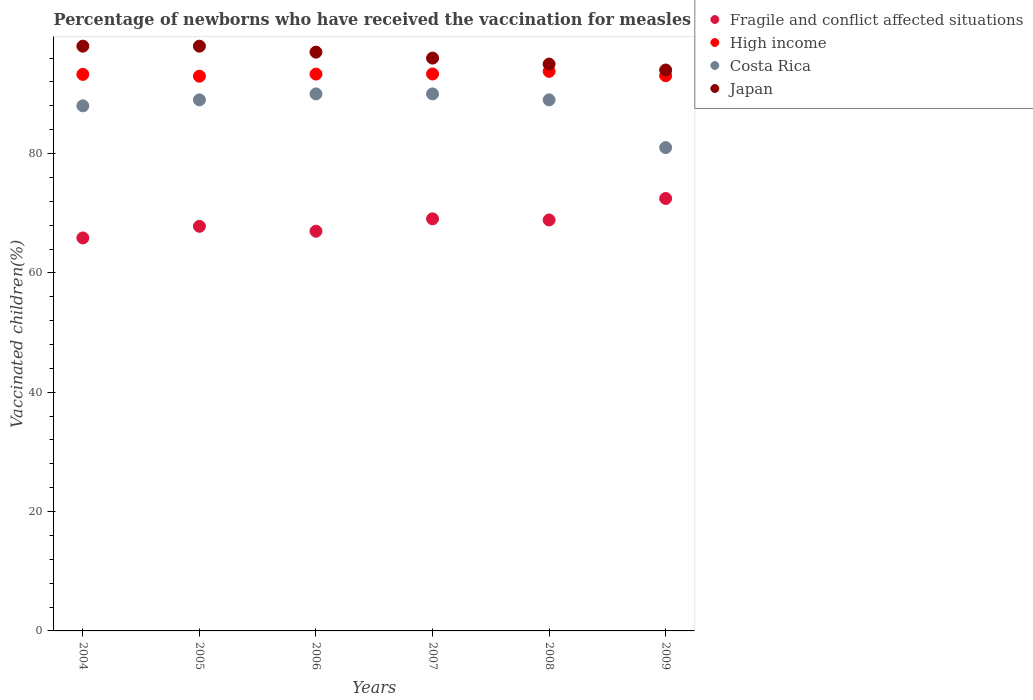How many different coloured dotlines are there?
Give a very brief answer. 4. Is the number of dotlines equal to the number of legend labels?
Your answer should be compact. Yes. What is the percentage of vaccinated children in High income in 2009?
Your answer should be compact. 93.05. Across all years, what is the maximum percentage of vaccinated children in Japan?
Your answer should be compact. 98. Across all years, what is the minimum percentage of vaccinated children in Fragile and conflict affected situations?
Provide a short and direct response. 65.86. What is the total percentage of vaccinated children in Japan in the graph?
Your answer should be compact. 578. What is the difference between the percentage of vaccinated children in Fragile and conflict affected situations in 2004 and that in 2006?
Your answer should be compact. -1.13. What is the difference between the percentage of vaccinated children in High income in 2006 and the percentage of vaccinated children in Japan in 2004?
Give a very brief answer. -4.68. What is the average percentage of vaccinated children in Japan per year?
Your answer should be compact. 96.33. In the year 2009, what is the difference between the percentage of vaccinated children in Fragile and conflict affected situations and percentage of vaccinated children in High income?
Offer a terse response. -20.57. In how many years, is the percentage of vaccinated children in Costa Rica greater than 48 %?
Your answer should be compact. 6. What is the ratio of the percentage of vaccinated children in High income in 2005 to that in 2008?
Your response must be concise. 0.99. What is the difference between the highest and the second highest percentage of vaccinated children in Fragile and conflict affected situations?
Provide a succinct answer. 3.41. What is the difference between the highest and the lowest percentage of vaccinated children in Fragile and conflict affected situations?
Ensure brevity in your answer.  6.61. In how many years, is the percentage of vaccinated children in Japan greater than the average percentage of vaccinated children in Japan taken over all years?
Make the answer very short. 3. Is the sum of the percentage of vaccinated children in Costa Rica in 2008 and 2009 greater than the maximum percentage of vaccinated children in Japan across all years?
Offer a very short reply. Yes. What is the title of the graph?
Offer a terse response. Percentage of newborns who have received the vaccination for measles. What is the label or title of the Y-axis?
Your response must be concise. Vaccinated children(%). What is the Vaccinated children(%) in Fragile and conflict affected situations in 2004?
Provide a succinct answer. 65.86. What is the Vaccinated children(%) of High income in 2004?
Provide a short and direct response. 93.27. What is the Vaccinated children(%) in Costa Rica in 2004?
Your response must be concise. 88. What is the Vaccinated children(%) of Fragile and conflict affected situations in 2005?
Your answer should be very brief. 67.81. What is the Vaccinated children(%) in High income in 2005?
Keep it short and to the point. 92.96. What is the Vaccinated children(%) of Costa Rica in 2005?
Give a very brief answer. 89. What is the Vaccinated children(%) in Japan in 2005?
Make the answer very short. 98. What is the Vaccinated children(%) in Fragile and conflict affected situations in 2006?
Offer a very short reply. 66.99. What is the Vaccinated children(%) in High income in 2006?
Your answer should be very brief. 93.32. What is the Vaccinated children(%) in Japan in 2006?
Give a very brief answer. 97. What is the Vaccinated children(%) in Fragile and conflict affected situations in 2007?
Ensure brevity in your answer.  69.06. What is the Vaccinated children(%) in High income in 2007?
Your answer should be very brief. 93.34. What is the Vaccinated children(%) in Costa Rica in 2007?
Your answer should be compact. 90. What is the Vaccinated children(%) in Japan in 2007?
Offer a terse response. 96. What is the Vaccinated children(%) in Fragile and conflict affected situations in 2008?
Make the answer very short. 68.87. What is the Vaccinated children(%) of High income in 2008?
Make the answer very short. 93.78. What is the Vaccinated children(%) of Costa Rica in 2008?
Provide a short and direct response. 89. What is the Vaccinated children(%) of Fragile and conflict affected situations in 2009?
Your answer should be very brief. 72.47. What is the Vaccinated children(%) in High income in 2009?
Provide a succinct answer. 93.05. What is the Vaccinated children(%) of Japan in 2009?
Offer a terse response. 94. Across all years, what is the maximum Vaccinated children(%) in Fragile and conflict affected situations?
Provide a short and direct response. 72.47. Across all years, what is the maximum Vaccinated children(%) in High income?
Give a very brief answer. 93.78. Across all years, what is the maximum Vaccinated children(%) in Japan?
Your answer should be compact. 98. Across all years, what is the minimum Vaccinated children(%) of Fragile and conflict affected situations?
Make the answer very short. 65.86. Across all years, what is the minimum Vaccinated children(%) in High income?
Your answer should be very brief. 92.96. Across all years, what is the minimum Vaccinated children(%) in Costa Rica?
Provide a succinct answer. 81. Across all years, what is the minimum Vaccinated children(%) of Japan?
Ensure brevity in your answer.  94. What is the total Vaccinated children(%) in Fragile and conflict affected situations in the graph?
Your response must be concise. 411.07. What is the total Vaccinated children(%) in High income in the graph?
Provide a succinct answer. 559.72. What is the total Vaccinated children(%) in Costa Rica in the graph?
Provide a succinct answer. 527. What is the total Vaccinated children(%) of Japan in the graph?
Provide a short and direct response. 578. What is the difference between the Vaccinated children(%) in Fragile and conflict affected situations in 2004 and that in 2005?
Ensure brevity in your answer.  -1.95. What is the difference between the Vaccinated children(%) of High income in 2004 and that in 2005?
Your answer should be compact. 0.31. What is the difference between the Vaccinated children(%) in Costa Rica in 2004 and that in 2005?
Make the answer very short. -1. What is the difference between the Vaccinated children(%) of Japan in 2004 and that in 2005?
Provide a succinct answer. 0. What is the difference between the Vaccinated children(%) of Fragile and conflict affected situations in 2004 and that in 2006?
Your answer should be very brief. -1.13. What is the difference between the Vaccinated children(%) of High income in 2004 and that in 2006?
Ensure brevity in your answer.  -0.05. What is the difference between the Vaccinated children(%) of Japan in 2004 and that in 2006?
Your response must be concise. 1. What is the difference between the Vaccinated children(%) in Fragile and conflict affected situations in 2004 and that in 2007?
Make the answer very short. -3.2. What is the difference between the Vaccinated children(%) in High income in 2004 and that in 2007?
Make the answer very short. -0.07. What is the difference between the Vaccinated children(%) in Costa Rica in 2004 and that in 2007?
Offer a very short reply. -2. What is the difference between the Vaccinated children(%) in Fragile and conflict affected situations in 2004 and that in 2008?
Give a very brief answer. -3.01. What is the difference between the Vaccinated children(%) of High income in 2004 and that in 2008?
Your answer should be very brief. -0.51. What is the difference between the Vaccinated children(%) in Costa Rica in 2004 and that in 2008?
Your answer should be very brief. -1. What is the difference between the Vaccinated children(%) of Fragile and conflict affected situations in 2004 and that in 2009?
Ensure brevity in your answer.  -6.61. What is the difference between the Vaccinated children(%) of High income in 2004 and that in 2009?
Your response must be concise. 0.22. What is the difference between the Vaccinated children(%) of Japan in 2004 and that in 2009?
Your answer should be compact. 4. What is the difference between the Vaccinated children(%) in Fragile and conflict affected situations in 2005 and that in 2006?
Your answer should be compact. 0.82. What is the difference between the Vaccinated children(%) in High income in 2005 and that in 2006?
Your answer should be very brief. -0.36. What is the difference between the Vaccinated children(%) in Costa Rica in 2005 and that in 2006?
Provide a short and direct response. -1. What is the difference between the Vaccinated children(%) in Japan in 2005 and that in 2006?
Your answer should be compact. 1. What is the difference between the Vaccinated children(%) of Fragile and conflict affected situations in 2005 and that in 2007?
Provide a short and direct response. -1.25. What is the difference between the Vaccinated children(%) in High income in 2005 and that in 2007?
Keep it short and to the point. -0.37. What is the difference between the Vaccinated children(%) in Japan in 2005 and that in 2007?
Give a very brief answer. 2. What is the difference between the Vaccinated children(%) in Fragile and conflict affected situations in 2005 and that in 2008?
Provide a short and direct response. -1.06. What is the difference between the Vaccinated children(%) in High income in 2005 and that in 2008?
Make the answer very short. -0.81. What is the difference between the Vaccinated children(%) of Costa Rica in 2005 and that in 2008?
Your answer should be very brief. 0. What is the difference between the Vaccinated children(%) of Japan in 2005 and that in 2008?
Your answer should be very brief. 3. What is the difference between the Vaccinated children(%) of Fragile and conflict affected situations in 2005 and that in 2009?
Ensure brevity in your answer.  -4.67. What is the difference between the Vaccinated children(%) of High income in 2005 and that in 2009?
Offer a terse response. -0.08. What is the difference between the Vaccinated children(%) of Fragile and conflict affected situations in 2006 and that in 2007?
Offer a very short reply. -2.07. What is the difference between the Vaccinated children(%) in High income in 2006 and that in 2007?
Offer a very short reply. -0.02. What is the difference between the Vaccinated children(%) in Japan in 2006 and that in 2007?
Provide a short and direct response. 1. What is the difference between the Vaccinated children(%) in Fragile and conflict affected situations in 2006 and that in 2008?
Your answer should be very brief. -1.88. What is the difference between the Vaccinated children(%) of High income in 2006 and that in 2008?
Your answer should be very brief. -0.46. What is the difference between the Vaccinated children(%) in Japan in 2006 and that in 2008?
Provide a succinct answer. 2. What is the difference between the Vaccinated children(%) of Fragile and conflict affected situations in 2006 and that in 2009?
Ensure brevity in your answer.  -5.49. What is the difference between the Vaccinated children(%) in High income in 2006 and that in 2009?
Keep it short and to the point. 0.27. What is the difference between the Vaccinated children(%) in Costa Rica in 2006 and that in 2009?
Your answer should be compact. 9. What is the difference between the Vaccinated children(%) of Fragile and conflict affected situations in 2007 and that in 2008?
Make the answer very short. 0.19. What is the difference between the Vaccinated children(%) in High income in 2007 and that in 2008?
Keep it short and to the point. -0.44. What is the difference between the Vaccinated children(%) in Costa Rica in 2007 and that in 2008?
Give a very brief answer. 1. What is the difference between the Vaccinated children(%) in Japan in 2007 and that in 2008?
Keep it short and to the point. 1. What is the difference between the Vaccinated children(%) in Fragile and conflict affected situations in 2007 and that in 2009?
Offer a very short reply. -3.41. What is the difference between the Vaccinated children(%) of High income in 2007 and that in 2009?
Keep it short and to the point. 0.29. What is the difference between the Vaccinated children(%) of Costa Rica in 2007 and that in 2009?
Your response must be concise. 9. What is the difference between the Vaccinated children(%) in Fragile and conflict affected situations in 2008 and that in 2009?
Keep it short and to the point. -3.6. What is the difference between the Vaccinated children(%) of High income in 2008 and that in 2009?
Offer a very short reply. 0.73. What is the difference between the Vaccinated children(%) in Fragile and conflict affected situations in 2004 and the Vaccinated children(%) in High income in 2005?
Give a very brief answer. -27.1. What is the difference between the Vaccinated children(%) in Fragile and conflict affected situations in 2004 and the Vaccinated children(%) in Costa Rica in 2005?
Your answer should be compact. -23.14. What is the difference between the Vaccinated children(%) in Fragile and conflict affected situations in 2004 and the Vaccinated children(%) in Japan in 2005?
Your answer should be compact. -32.14. What is the difference between the Vaccinated children(%) in High income in 2004 and the Vaccinated children(%) in Costa Rica in 2005?
Provide a short and direct response. 4.27. What is the difference between the Vaccinated children(%) of High income in 2004 and the Vaccinated children(%) of Japan in 2005?
Provide a short and direct response. -4.73. What is the difference between the Vaccinated children(%) of Costa Rica in 2004 and the Vaccinated children(%) of Japan in 2005?
Provide a short and direct response. -10. What is the difference between the Vaccinated children(%) in Fragile and conflict affected situations in 2004 and the Vaccinated children(%) in High income in 2006?
Give a very brief answer. -27.46. What is the difference between the Vaccinated children(%) in Fragile and conflict affected situations in 2004 and the Vaccinated children(%) in Costa Rica in 2006?
Offer a very short reply. -24.14. What is the difference between the Vaccinated children(%) of Fragile and conflict affected situations in 2004 and the Vaccinated children(%) of Japan in 2006?
Make the answer very short. -31.14. What is the difference between the Vaccinated children(%) in High income in 2004 and the Vaccinated children(%) in Costa Rica in 2006?
Offer a terse response. 3.27. What is the difference between the Vaccinated children(%) of High income in 2004 and the Vaccinated children(%) of Japan in 2006?
Your answer should be compact. -3.73. What is the difference between the Vaccinated children(%) in Fragile and conflict affected situations in 2004 and the Vaccinated children(%) in High income in 2007?
Ensure brevity in your answer.  -27.48. What is the difference between the Vaccinated children(%) in Fragile and conflict affected situations in 2004 and the Vaccinated children(%) in Costa Rica in 2007?
Give a very brief answer. -24.14. What is the difference between the Vaccinated children(%) in Fragile and conflict affected situations in 2004 and the Vaccinated children(%) in Japan in 2007?
Your response must be concise. -30.14. What is the difference between the Vaccinated children(%) in High income in 2004 and the Vaccinated children(%) in Costa Rica in 2007?
Make the answer very short. 3.27. What is the difference between the Vaccinated children(%) in High income in 2004 and the Vaccinated children(%) in Japan in 2007?
Your answer should be compact. -2.73. What is the difference between the Vaccinated children(%) in Fragile and conflict affected situations in 2004 and the Vaccinated children(%) in High income in 2008?
Your answer should be very brief. -27.92. What is the difference between the Vaccinated children(%) in Fragile and conflict affected situations in 2004 and the Vaccinated children(%) in Costa Rica in 2008?
Your answer should be very brief. -23.14. What is the difference between the Vaccinated children(%) in Fragile and conflict affected situations in 2004 and the Vaccinated children(%) in Japan in 2008?
Provide a short and direct response. -29.14. What is the difference between the Vaccinated children(%) in High income in 2004 and the Vaccinated children(%) in Costa Rica in 2008?
Ensure brevity in your answer.  4.27. What is the difference between the Vaccinated children(%) of High income in 2004 and the Vaccinated children(%) of Japan in 2008?
Offer a terse response. -1.73. What is the difference between the Vaccinated children(%) of Fragile and conflict affected situations in 2004 and the Vaccinated children(%) of High income in 2009?
Provide a succinct answer. -27.19. What is the difference between the Vaccinated children(%) in Fragile and conflict affected situations in 2004 and the Vaccinated children(%) in Costa Rica in 2009?
Offer a very short reply. -15.14. What is the difference between the Vaccinated children(%) in Fragile and conflict affected situations in 2004 and the Vaccinated children(%) in Japan in 2009?
Make the answer very short. -28.14. What is the difference between the Vaccinated children(%) in High income in 2004 and the Vaccinated children(%) in Costa Rica in 2009?
Make the answer very short. 12.27. What is the difference between the Vaccinated children(%) in High income in 2004 and the Vaccinated children(%) in Japan in 2009?
Give a very brief answer. -0.73. What is the difference between the Vaccinated children(%) in Fragile and conflict affected situations in 2005 and the Vaccinated children(%) in High income in 2006?
Offer a terse response. -25.51. What is the difference between the Vaccinated children(%) of Fragile and conflict affected situations in 2005 and the Vaccinated children(%) of Costa Rica in 2006?
Make the answer very short. -22.19. What is the difference between the Vaccinated children(%) of Fragile and conflict affected situations in 2005 and the Vaccinated children(%) of Japan in 2006?
Offer a very short reply. -29.19. What is the difference between the Vaccinated children(%) of High income in 2005 and the Vaccinated children(%) of Costa Rica in 2006?
Give a very brief answer. 2.96. What is the difference between the Vaccinated children(%) in High income in 2005 and the Vaccinated children(%) in Japan in 2006?
Offer a very short reply. -4.04. What is the difference between the Vaccinated children(%) in Costa Rica in 2005 and the Vaccinated children(%) in Japan in 2006?
Provide a short and direct response. -8. What is the difference between the Vaccinated children(%) of Fragile and conflict affected situations in 2005 and the Vaccinated children(%) of High income in 2007?
Provide a short and direct response. -25.53. What is the difference between the Vaccinated children(%) of Fragile and conflict affected situations in 2005 and the Vaccinated children(%) of Costa Rica in 2007?
Your answer should be compact. -22.19. What is the difference between the Vaccinated children(%) in Fragile and conflict affected situations in 2005 and the Vaccinated children(%) in Japan in 2007?
Your response must be concise. -28.19. What is the difference between the Vaccinated children(%) of High income in 2005 and the Vaccinated children(%) of Costa Rica in 2007?
Offer a terse response. 2.96. What is the difference between the Vaccinated children(%) in High income in 2005 and the Vaccinated children(%) in Japan in 2007?
Your answer should be very brief. -3.04. What is the difference between the Vaccinated children(%) in Fragile and conflict affected situations in 2005 and the Vaccinated children(%) in High income in 2008?
Provide a succinct answer. -25.97. What is the difference between the Vaccinated children(%) of Fragile and conflict affected situations in 2005 and the Vaccinated children(%) of Costa Rica in 2008?
Offer a terse response. -21.19. What is the difference between the Vaccinated children(%) in Fragile and conflict affected situations in 2005 and the Vaccinated children(%) in Japan in 2008?
Provide a short and direct response. -27.19. What is the difference between the Vaccinated children(%) of High income in 2005 and the Vaccinated children(%) of Costa Rica in 2008?
Your response must be concise. 3.96. What is the difference between the Vaccinated children(%) of High income in 2005 and the Vaccinated children(%) of Japan in 2008?
Make the answer very short. -2.04. What is the difference between the Vaccinated children(%) in Costa Rica in 2005 and the Vaccinated children(%) in Japan in 2008?
Your response must be concise. -6. What is the difference between the Vaccinated children(%) of Fragile and conflict affected situations in 2005 and the Vaccinated children(%) of High income in 2009?
Provide a short and direct response. -25.24. What is the difference between the Vaccinated children(%) in Fragile and conflict affected situations in 2005 and the Vaccinated children(%) in Costa Rica in 2009?
Your response must be concise. -13.19. What is the difference between the Vaccinated children(%) of Fragile and conflict affected situations in 2005 and the Vaccinated children(%) of Japan in 2009?
Give a very brief answer. -26.19. What is the difference between the Vaccinated children(%) in High income in 2005 and the Vaccinated children(%) in Costa Rica in 2009?
Keep it short and to the point. 11.96. What is the difference between the Vaccinated children(%) of High income in 2005 and the Vaccinated children(%) of Japan in 2009?
Offer a terse response. -1.04. What is the difference between the Vaccinated children(%) of Costa Rica in 2005 and the Vaccinated children(%) of Japan in 2009?
Offer a very short reply. -5. What is the difference between the Vaccinated children(%) in Fragile and conflict affected situations in 2006 and the Vaccinated children(%) in High income in 2007?
Keep it short and to the point. -26.35. What is the difference between the Vaccinated children(%) of Fragile and conflict affected situations in 2006 and the Vaccinated children(%) of Costa Rica in 2007?
Offer a terse response. -23.01. What is the difference between the Vaccinated children(%) of Fragile and conflict affected situations in 2006 and the Vaccinated children(%) of Japan in 2007?
Your answer should be compact. -29.01. What is the difference between the Vaccinated children(%) in High income in 2006 and the Vaccinated children(%) in Costa Rica in 2007?
Your answer should be compact. 3.32. What is the difference between the Vaccinated children(%) in High income in 2006 and the Vaccinated children(%) in Japan in 2007?
Give a very brief answer. -2.68. What is the difference between the Vaccinated children(%) in Costa Rica in 2006 and the Vaccinated children(%) in Japan in 2007?
Your response must be concise. -6. What is the difference between the Vaccinated children(%) in Fragile and conflict affected situations in 2006 and the Vaccinated children(%) in High income in 2008?
Your answer should be compact. -26.79. What is the difference between the Vaccinated children(%) of Fragile and conflict affected situations in 2006 and the Vaccinated children(%) of Costa Rica in 2008?
Offer a terse response. -22.01. What is the difference between the Vaccinated children(%) of Fragile and conflict affected situations in 2006 and the Vaccinated children(%) of Japan in 2008?
Make the answer very short. -28.01. What is the difference between the Vaccinated children(%) in High income in 2006 and the Vaccinated children(%) in Costa Rica in 2008?
Offer a terse response. 4.32. What is the difference between the Vaccinated children(%) of High income in 2006 and the Vaccinated children(%) of Japan in 2008?
Offer a very short reply. -1.68. What is the difference between the Vaccinated children(%) in Costa Rica in 2006 and the Vaccinated children(%) in Japan in 2008?
Offer a very short reply. -5. What is the difference between the Vaccinated children(%) in Fragile and conflict affected situations in 2006 and the Vaccinated children(%) in High income in 2009?
Offer a terse response. -26.06. What is the difference between the Vaccinated children(%) of Fragile and conflict affected situations in 2006 and the Vaccinated children(%) of Costa Rica in 2009?
Your response must be concise. -14.01. What is the difference between the Vaccinated children(%) of Fragile and conflict affected situations in 2006 and the Vaccinated children(%) of Japan in 2009?
Ensure brevity in your answer.  -27.01. What is the difference between the Vaccinated children(%) in High income in 2006 and the Vaccinated children(%) in Costa Rica in 2009?
Provide a succinct answer. 12.32. What is the difference between the Vaccinated children(%) in High income in 2006 and the Vaccinated children(%) in Japan in 2009?
Ensure brevity in your answer.  -0.68. What is the difference between the Vaccinated children(%) of Costa Rica in 2006 and the Vaccinated children(%) of Japan in 2009?
Make the answer very short. -4. What is the difference between the Vaccinated children(%) of Fragile and conflict affected situations in 2007 and the Vaccinated children(%) of High income in 2008?
Offer a very short reply. -24.72. What is the difference between the Vaccinated children(%) of Fragile and conflict affected situations in 2007 and the Vaccinated children(%) of Costa Rica in 2008?
Offer a very short reply. -19.94. What is the difference between the Vaccinated children(%) in Fragile and conflict affected situations in 2007 and the Vaccinated children(%) in Japan in 2008?
Your answer should be very brief. -25.94. What is the difference between the Vaccinated children(%) in High income in 2007 and the Vaccinated children(%) in Costa Rica in 2008?
Provide a succinct answer. 4.34. What is the difference between the Vaccinated children(%) of High income in 2007 and the Vaccinated children(%) of Japan in 2008?
Provide a short and direct response. -1.66. What is the difference between the Vaccinated children(%) of Costa Rica in 2007 and the Vaccinated children(%) of Japan in 2008?
Provide a short and direct response. -5. What is the difference between the Vaccinated children(%) of Fragile and conflict affected situations in 2007 and the Vaccinated children(%) of High income in 2009?
Ensure brevity in your answer.  -23.99. What is the difference between the Vaccinated children(%) of Fragile and conflict affected situations in 2007 and the Vaccinated children(%) of Costa Rica in 2009?
Offer a terse response. -11.94. What is the difference between the Vaccinated children(%) in Fragile and conflict affected situations in 2007 and the Vaccinated children(%) in Japan in 2009?
Provide a succinct answer. -24.94. What is the difference between the Vaccinated children(%) of High income in 2007 and the Vaccinated children(%) of Costa Rica in 2009?
Ensure brevity in your answer.  12.34. What is the difference between the Vaccinated children(%) of High income in 2007 and the Vaccinated children(%) of Japan in 2009?
Ensure brevity in your answer.  -0.66. What is the difference between the Vaccinated children(%) of Fragile and conflict affected situations in 2008 and the Vaccinated children(%) of High income in 2009?
Make the answer very short. -24.18. What is the difference between the Vaccinated children(%) of Fragile and conflict affected situations in 2008 and the Vaccinated children(%) of Costa Rica in 2009?
Your response must be concise. -12.13. What is the difference between the Vaccinated children(%) of Fragile and conflict affected situations in 2008 and the Vaccinated children(%) of Japan in 2009?
Offer a terse response. -25.13. What is the difference between the Vaccinated children(%) in High income in 2008 and the Vaccinated children(%) in Costa Rica in 2009?
Make the answer very short. 12.78. What is the difference between the Vaccinated children(%) in High income in 2008 and the Vaccinated children(%) in Japan in 2009?
Provide a short and direct response. -0.22. What is the average Vaccinated children(%) in Fragile and conflict affected situations per year?
Provide a succinct answer. 68.51. What is the average Vaccinated children(%) in High income per year?
Ensure brevity in your answer.  93.29. What is the average Vaccinated children(%) in Costa Rica per year?
Your response must be concise. 87.83. What is the average Vaccinated children(%) of Japan per year?
Keep it short and to the point. 96.33. In the year 2004, what is the difference between the Vaccinated children(%) in Fragile and conflict affected situations and Vaccinated children(%) in High income?
Offer a terse response. -27.41. In the year 2004, what is the difference between the Vaccinated children(%) of Fragile and conflict affected situations and Vaccinated children(%) of Costa Rica?
Give a very brief answer. -22.14. In the year 2004, what is the difference between the Vaccinated children(%) of Fragile and conflict affected situations and Vaccinated children(%) of Japan?
Provide a short and direct response. -32.14. In the year 2004, what is the difference between the Vaccinated children(%) of High income and Vaccinated children(%) of Costa Rica?
Provide a succinct answer. 5.27. In the year 2004, what is the difference between the Vaccinated children(%) in High income and Vaccinated children(%) in Japan?
Make the answer very short. -4.73. In the year 2004, what is the difference between the Vaccinated children(%) of Costa Rica and Vaccinated children(%) of Japan?
Ensure brevity in your answer.  -10. In the year 2005, what is the difference between the Vaccinated children(%) in Fragile and conflict affected situations and Vaccinated children(%) in High income?
Ensure brevity in your answer.  -25.16. In the year 2005, what is the difference between the Vaccinated children(%) of Fragile and conflict affected situations and Vaccinated children(%) of Costa Rica?
Ensure brevity in your answer.  -21.19. In the year 2005, what is the difference between the Vaccinated children(%) in Fragile and conflict affected situations and Vaccinated children(%) in Japan?
Make the answer very short. -30.19. In the year 2005, what is the difference between the Vaccinated children(%) in High income and Vaccinated children(%) in Costa Rica?
Offer a terse response. 3.96. In the year 2005, what is the difference between the Vaccinated children(%) in High income and Vaccinated children(%) in Japan?
Your response must be concise. -5.04. In the year 2005, what is the difference between the Vaccinated children(%) of Costa Rica and Vaccinated children(%) of Japan?
Provide a succinct answer. -9. In the year 2006, what is the difference between the Vaccinated children(%) in Fragile and conflict affected situations and Vaccinated children(%) in High income?
Your answer should be very brief. -26.33. In the year 2006, what is the difference between the Vaccinated children(%) of Fragile and conflict affected situations and Vaccinated children(%) of Costa Rica?
Offer a very short reply. -23.01. In the year 2006, what is the difference between the Vaccinated children(%) in Fragile and conflict affected situations and Vaccinated children(%) in Japan?
Provide a succinct answer. -30.01. In the year 2006, what is the difference between the Vaccinated children(%) in High income and Vaccinated children(%) in Costa Rica?
Make the answer very short. 3.32. In the year 2006, what is the difference between the Vaccinated children(%) in High income and Vaccinated children(%) in Japan?
Provide a short and direct response. -3.68. In the year 2006, what is the difference between the Vaccinated children(%) in Costa Rica and Vaccinated children(%) in Japan?
Provide a short and direct response. -7. In the year 2007, what is the difference between the Vaccinated children(%) of Fragile and conflict affected situations and Vaccinated children(%) of High income?
Give a very brief answer. -24.28. In the year 2007, what is the difference between the Vaccinated children(%) in Fragile and conflict affected situations and Vaccinated children(%) in Costa Rica?
Keep it short and to the point. -20.94. In the year 2007, what is the difference between the Vaccinated children(%) in Fragile and conflict affected situations and Vaccinated children(%) in Japan?
Ensure brevity in your answer.  -26.94. In the year 2007, what is the difference between the Vaccinated children(%) in High income and Vaccinated children(%) in Costa Rica?
Offer a terse response. 3.34. In the year 2007, what is the difference between the Vaccinated children(%) of High income and Vaccinated children(%) of Japan?
Provide a succinct answer. -2.66. In the year 2008, what is the difference between the Vaccinated children(%) in Fragile and conflict affected situations and Vaccinated children(%) in High income?
Your answer should be compact. -24.91. In the year 2008, what is the difference between the Vaccinated children(%) of Fragile and conflict affected situations and Vaccinated children(%) of Costa Rica?
Give a very brief answer. -20.13. In the year 2008, what is the difference between the Vaccinated children(%) of Fragile and conflict affected situations and Vaccinated children(%) of Japan?
Ensure brevity in your answer.  -26.13. In the year 2008, what is the difference between the Vaccinated children(%) in High income and Vaccinated children(%) in Costa Rica?
Your response must be concise. 4.78. In the year 2008, what is the difference between the Vaccinated children(%) of High income and Vaccinated children(%) of Japan?
Offer a terse response. -1.22. In the year 2008, what is the difference between the Vaccinated children(%) of Costa Rica and Vaccinated children(%) of Japan?
Offer a very short reply. -6. In the year 2009, what is the difference between the Vaccinated children(%) in Fragile and conflict affected situations and Vaccinated children(%) in High income?
Keep it short and to the point. -20.57. In the year 2009, what is the difference between the Vaccinated children(%) in Fragile and conflict affected situations and Vaccinated children(%) in Costa Rica?
Your response must be concise. -8.53. In the year 2009, what is the difference between the Vaccinated children(%) of Fragile and conflict affected situations and Vaccinated children(%) of Japan?
Ensure brevity in your answer.  -21.53. In the year 2009, what is the difference between the Vaccinated children(%) of High income and Vaccinated children(%) of Costa Rica?
Make the answer very short. 12.05. In the year 2009, what is the difference between the Vaccinated children(%) of High income and Vaccinated children(%) of Japan?
Provide a succinct answer. -0.95. In the year 2009, what is the difference between the Vaccinated children(%) in Costa Rica and Vaccinated children(%) in Japan?
Provide a short and direct response. -13. What is the ratio of the Vaccinated children(%) in Fragile and conflict affected situations in 2004 to that in 2005?
Your response must be concise. 0.97. What is the ratio of the Vaccinated children(%) in Costa Rica in 2004 to that in 2005?
Keep it short and to the point. 0.99. What is the ratio of the Vaccinated children(%) in Japan in 2004 to that in 2005?
Your answer should be compact. 1. What is the ratio of the Vaccinated children(%) in Fragile and conflict affected situations in 2004 to that in 2006?
Provide a short and direct response. 0.98. What is the ratio of the Vaccinated children(%) in High income in 2004 to that in 2006?
Offer a terse response. 1. What is the ratio of the Vaccinated children(%) in Costa Rica in 2004 to that in 2006?
Provide a short and direct response. 0.98. What is the ratio of the Vaccinated children(%) of Japan in 2004 to that in 2006?
Give a very brief answer. 1.01. What is the ratio of the Vaccinated children(%) in Fragile and conflict affected situations in 2004 to that in 2007?
Your answer should be very brief. 0.95. What is the ratio of the Vaccinated children(%) in Costa Rica in 2004 to that in 2007?
Your response must be concise. 0.98. What is the ratio of the Vaccinated children(%) of Japan in 2004 to that in 2007?
Provide a short and direct response. 1.02. What is the ratio of the Vaccinated children(%) of Fragile and conflict affected situations in 2004 to that in 2008?
Your answer should be compact. 0.96. What is the ratio of the Vaccinated children(%) in High income in 2004 to that in 2008?
Ensure brevity in your answer.  0.99. What is the ratio of the Vaccinated children(%) in Costa Rica in 2004 to that in 2008?
Offer a very short reply. 0.99. What is the ratio of the Vaccinated children(%) in Japan in 2004 to that in 2008?
Make the answer very short. 1.03. What is the ratio of the Vaccinated children(%) of Fragile and conflict affected situations in 2004 to that in 2009?
Give a very brief answer. 0.91. What is the ratio of the Vaccinated children(%) in Costa Rica in 2004 to that in 2009?
Provide a short and direct response. 1.09. What is the ratio of the Vaccinated children(%) in Japan in 2004 to that in 2009?
Provide a succinct answer. 1.04. What is the ratio of the Vaccinated children(%) in Fragile and conflict affected situations in 2005 to that in 2006?
Offer a very short reply. 1.01. What is the ratio of the Vaccinated children(%) in Costa Rica in 2005 to that in 2006?
Your response must be concise. 0.99. What is the ratio of the Vaccinated children(%) of Japan in 2005 to that in 2006?
Offer a terse response. 1.01. What is the ratio of the Vaccinated children(%) in Fragile and conflict affected situations in 2005 to that in 2007?
Provide a succinct answer. 0.98. What is the ratio of the Vaccinated children(%) of High income in 2005 to that in 2007?
Offer a very short reply. 1. What is the ratio of the Vaccinated children(%) in Costa Rica in 2005 to that in 2007?
Provide a succinct answer. 0.99. What is the ratio of the Vaccinated children(%) of Japan in 2005 to that in 2007?
Provide a short and direct response. 1.02. What is the ratio of the Vaccinated children(%) of Fragile and conflict affected situations in 2005 to that in 2008?
Provide a succinct answer. 0.98. What is the ratio of the Vaccinated children(%) in Japan in 2005 to that in 2008?
Make the answer very short. 1.03. What is the ratio of the Vaccinated children(%) in Fragile and conflict affected situations in 2005 to that in 2009?
Keep it short and to the point. 0.94. What is the ratio of the Vaccinated children(%) in Costa Rica in 2005 to that in 2009?
Your answer should be very brief. 1.1. What is the ratio of the Vaccinated children(%) in Japan in 2005 to that in 2009?
Provide a succinct answer. 1.04. What is the ratio of the Vaccinated children(%) of Fragile and conflict affected situations in 2006 to that in 2007?
Offer a terse response. 0.97. What is the ratio of the Vaccinated children(%) of Costa Rica in 2006 to that in 2007?
Ensure brevity in your answer.  1. What is the ratio of the Vaccinated children(%) of Japan in 2006 to that in 2007?
Keep it short and to the point. 1.01. What is the ratio of the Vaccinated children(%) of Fragile and conflict affected situations in 2006 to that in 2008?
Offer a very short reply. 0.97. What is the ratio of the Vaccinated children(%) of Costa Rica in 2006 to that in 2008?
Provide a short and direct response. 1.01. What is the ratio of the Vaccinated children(%) of Japan in 2006 to that in 2008?
Offer a very short reply. 1.02. What is the ratio of the Vaccinated children(%) of Fragile and conflict affected situations in 2006 to that in 2009?
Provide a succinct answer. 0.92. What is the ratio of the Vaccinated children(%) in Costa Rica in 2006 to that in 2009?
Your answer should be compact. 1.11. What is the ratio of the Vaccinated children(%) in Japan in 2006 to that in 2009?
Offer a very short reply. 1.03. What is the ratio of the Vaccinated children(%) in Fragile and conflict affected situations in 2007 to that in 2008?
Offer a very short reply. 1. What is the ratio of the Vaccinated children(%) of High income in 2007 to that in 2008?
Provide a short and direct response. 1. What is the ratio of the Vaccinated children(%) in Costa Rica in 2007 to that in 2008?
Provide a succinct answer. 1.01. What is the ratio of the Vaccinated children(%) of Japan in 2007 to that in 2008?
Provide a succinct answer. 1.01. What is the ratio of the Vaccinated children(%) in Fragile and conflict affected situations in 2007 to that in 2009?
Your answer should be compact. 0.95. What is the ratio of the Vaccinated children(%) in High income in 2007 to that in 2009?
Make the answer very short. 1. What is the ratio of the Vaccinated children(%) of Costa Rica in 2007 to that in 2009?
Your response must be concise. 1.11. What is the ratio of the Vaccinated children(%) of Japan in 2007 to that in 2009?
Your answer should be very brief. 1.02. What is the ratio of the Vaccinated children(%) in Fragile and conflict affected situations in 2008 to that in 2009?
Provide a succinct answer. 0.95. What is the ratio of the Vaccinated children(%) in Costa Rica in 2008 to that in 2009?
Your response must be concise. 1.1. What is the ratio of the Vaccinated children(%) of Japan in 2008 to that in 2009?
Keep it short and to the point. 1.01. What is the difference between the highest and the second highest Vaccinated children(%) in Fragile and conflict affected situations?
Your response must be concise. 3.41. What is the difference between the highest and the second highest Vaccinated children(%) in High income?
Keep it short and to the point. 0.44. What is the difference between the highest and the lowest Vaccinated children(%) of Fragile and conflict affected situations?
Your response must be concise. 6.61. What is the difference between the highest and the lowest Vaccinated children(%) in High income?
Keep it short and to the point. 0.81. What is the difference between the highest and the lowest Vaccinated children(%) in Costa Rica?
Give a very brief answer. 9. 